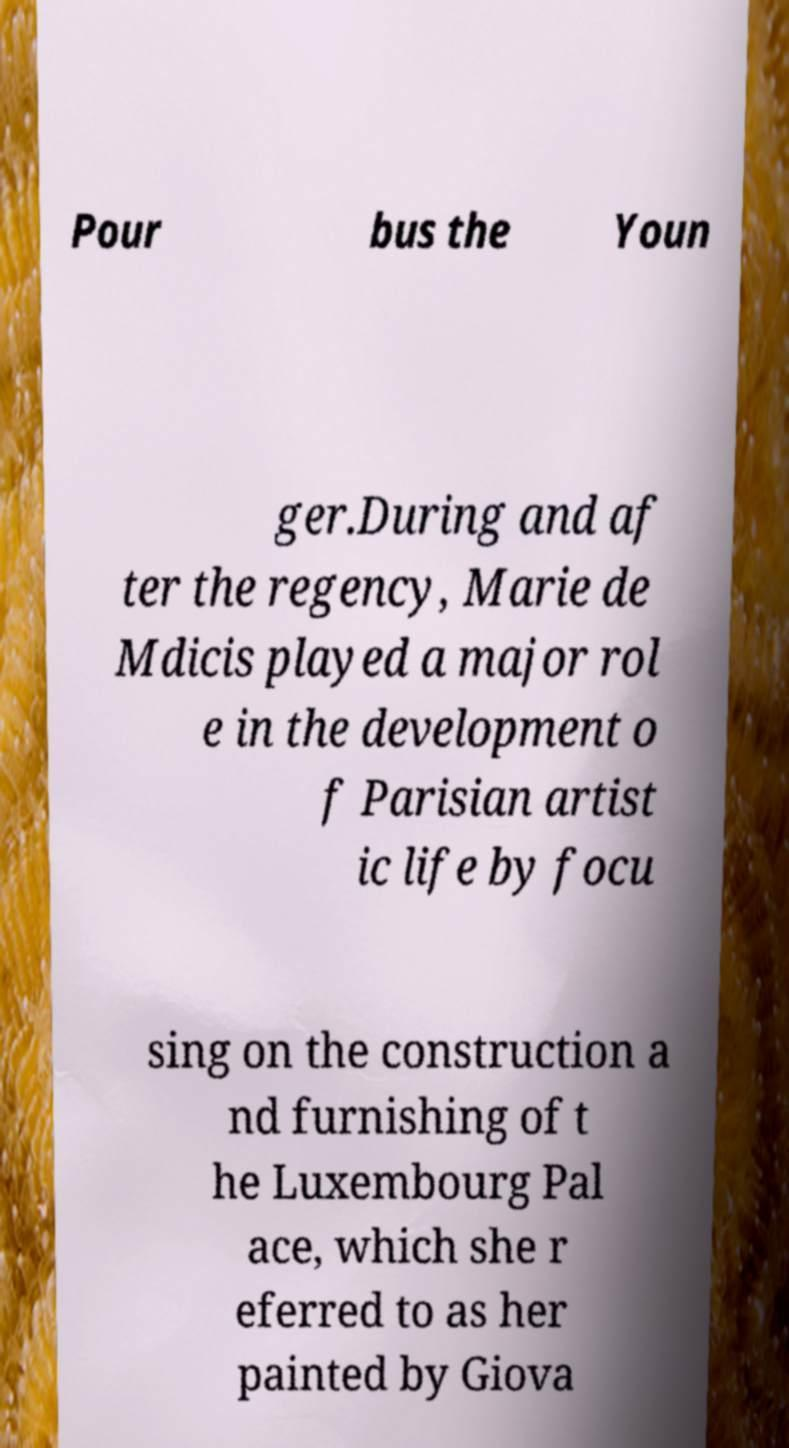Please read and relay the text visible in this image. What does it say? Pour bus the Youn ger.During and af ter the regency, Marie de Mdicis played a major rol e in the development o f Parisian artist ic life by focu sing on the construction a nd furnishing of t he Luxembourg Pal ace, which she r eferred to as her painted by Giova 